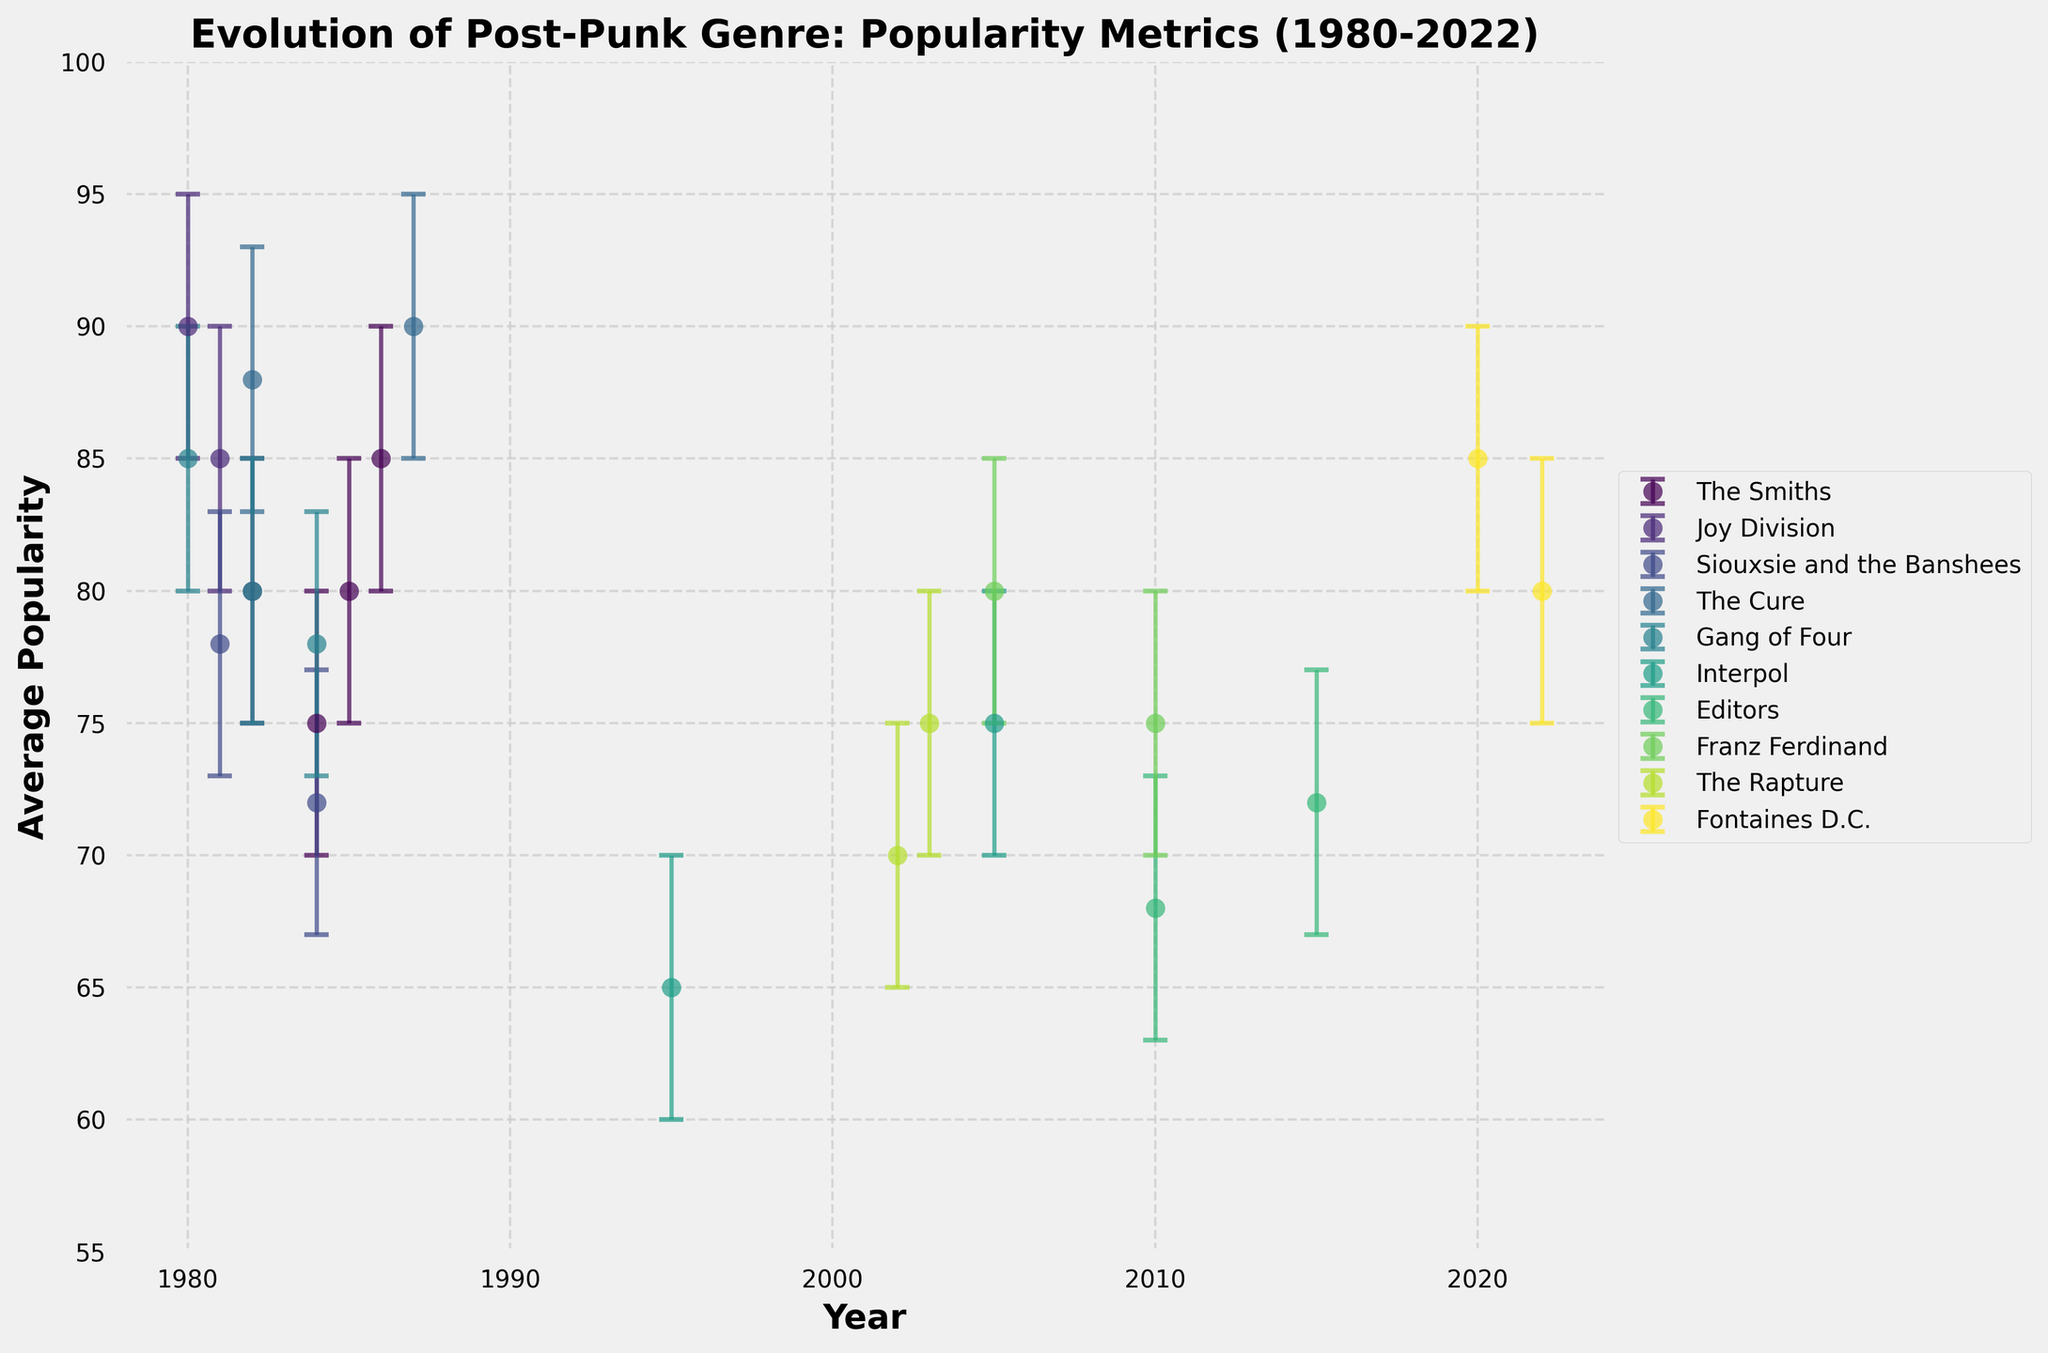What's the title of the figure? The title of the figure is usually written in a larger font size at the top of the chart. By looking at the top of the chart, you can see that the title is "Evolution of Post-Punk Genre: Popularity Metrics (1980-2022)".
Answer: Evolution of Post-Punk Genre: Popularity Metrics (1980-2022) What years do the x-axis cover? The x-axis shows the years increasing from left to right. By examining the axis, it begins at 1978 and ends at 2024, according to the limits set on the plot.
Answer: 1978 to 2024 Which band has the highest average popularity in 1980? To find this, look for the year 1980 on the x-axis and compare the average popularity values for the bands at that year. Joy Division has an average popularity of 90, the highest for that year.
Answer: Joy Division Which year shows the highest popularity for The Smiths and what is that value? First, locate all the points corresponding to The Smiths. Then, identify the point with the highest popularity. The highest value is 85 in the year 1986.
Answer: 1986, 85 How does the popularity of Interpol change from 1995 to 2005? Locate the data points for Interpol in 1995 and 2005. In 1995, the popularity is 65, and in 2005, it is 75. The change is calculated as 75 - 65 = 10.
Answer: Increases by 10 Which band has the greatest variation in popularity over the years (highest range of error bars)? To determine this, check the range of the error bars for each band by identifying the maximum and minimum values for the error bars. Joy Division has the widest range between 85 and 95.
Answer: Joy Division How do the popularity trends of The Cure compare between 1982 and 1987? Locate the data points for The Cure in 1982 and 1987. The popularity in 1982 is 88 and increases to 90 in 1987. This showcases a similar high level of popularity without significant change over the years.
Answer: Similar high popularity with a slight increase What is the average popularity of Fontaines D.C. across all the years shown? Identify the data points for Fontaines D.C., which are 2020 and 2022 with popularity values of 85 and 80. Calculate the average: (85 + 80) / 2 = 82.5.
Answer: 82.5 Which post-2000 band has the highest average popularity, and what is the value? Look at the data points for all bands existing after the year 2000. Fontaines D.C. has the highest values of 85 in 2020 and an average of 82.5 over the years shown.
Answer: Fontaines D.C., 85 